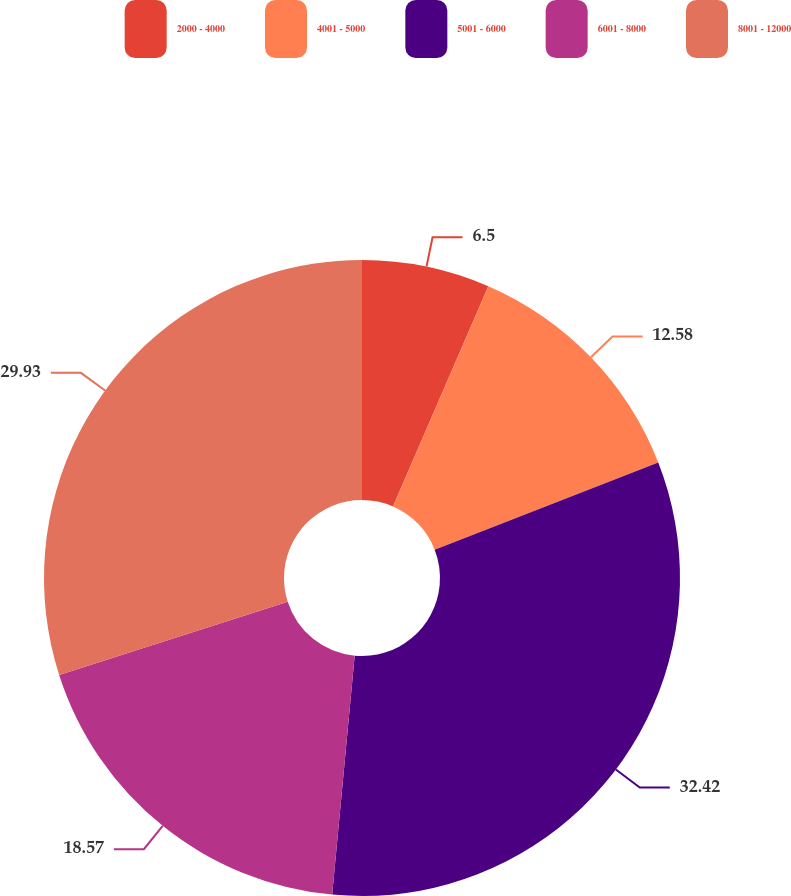Convert chart. <chart><loc_0><loc_0><loc_500><loc_500><pie_chart><fcel>2000 - 4000<fcel>4001 - 5000<fcel>5001 - 6000<fcel>6001 - 8000<fcel>8001 - 12000<nl><fcel>6.5%<fcel>12.58%<fcel>32.41%<fcel>18.57%<fcel>29.93%<nl></chart> 